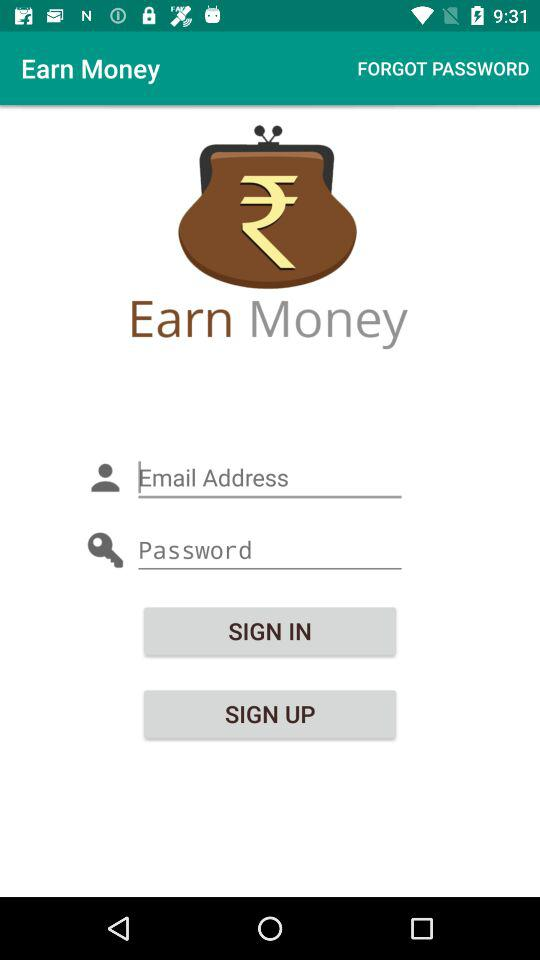What is the application name? The application name is "Earn Money". 